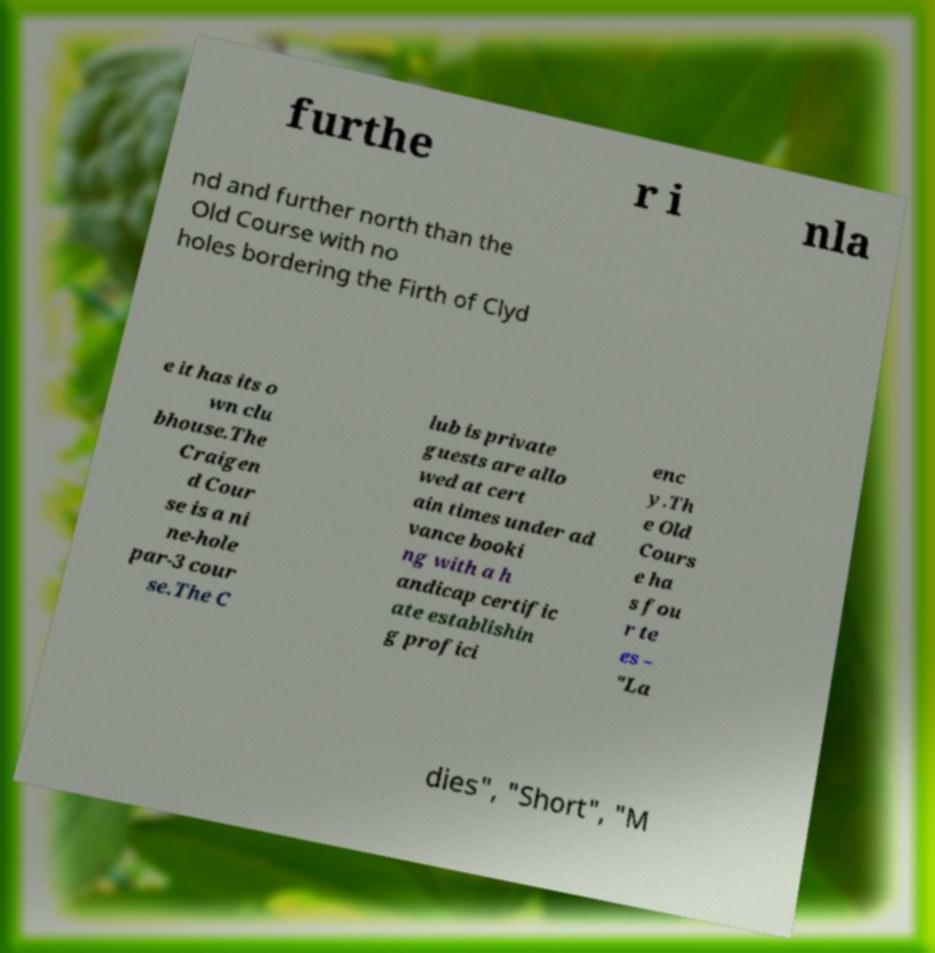Please identify and transcribe the text found in this image. furthe r i nla nd and further north than the Old Course with no holes bordering the Firth of Clyd e it has its o wn clu bhouse.The Craigen d Cour se is a ni ne-hole par-3 cour se.The C lub is private guests are allo wed at cert ain times under ad vance booki ng with a h andicap certific ate establishin g profici enc y.Th e Old Cours e ha s fou r te es – "La dies", "Short", "M 